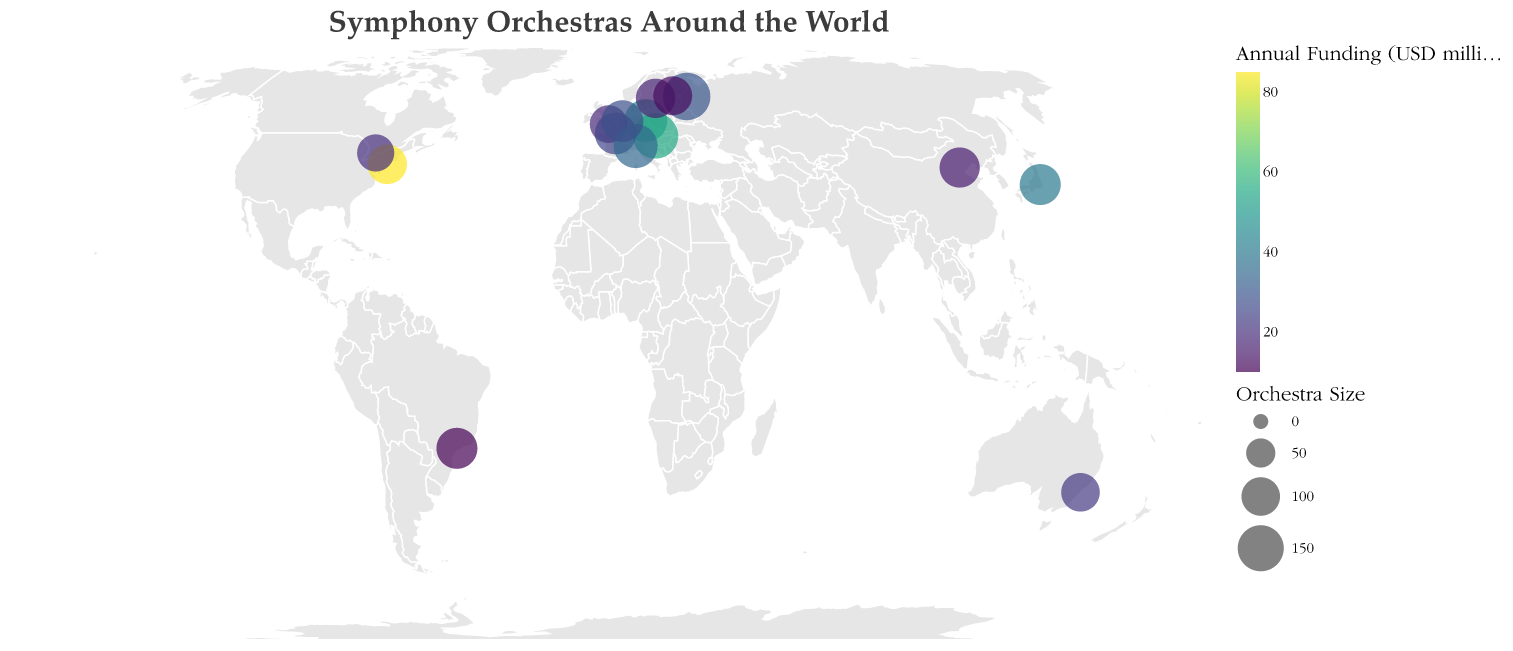What is the size of the New York Philharmonic orchestra? Look at the circle representing the New York Philharmonic in New York and refer to the size legend. The size is listed as 106.
Answer: 106 Which orchestra has the largest annual funding? Identify the orchestra with the most intense color indicating high funding. The New York Philharmonic in the United States has the highest funding of 85 million USD annually.
Answer: New York Philharmonic How many orchestras have an annual funding of 30 million USD or more? Count the circles with color intensity indicating 30 million USD or more. The orchestras are New York Philharmonic, Berlin Philharmonic, Vienna Philharmonic, and NHK Symphony Orchestra, totaling 4.
Answer: 4 Which orchestra has the smallest size under 100 members? Find the smallest circles and check their specific sizes. The London Symphony Orchestra has the smallest size of 95.
Answer: London Symphony Orchestra What is the average size of the orchestras in Europe? Identify the European orchestras (Berlin Philharmonic, London Symphony Orchestra, Vienna Philharmonic, Mariinsky Theatre Orchestra, Orchestre de Paris, La Scala Theatre Orchestra, Royal Concertgebouw Orchestra, Royal Stockholm Philharmonic, Helsinki Philharmonic Orchestra) and compute their average size. (128 + 95 + 145 + 160 + 119 + 135 + 120 + 105 + 102) / 9 = 123.22
Answer: 123.22 Which orchestra is located in the southern hemisphere? Locate the orchestras in the southern hemisphere by geographical position below the equator. The Sydney Symphony Orchestra in Australia is the one located there.
Answer: Sydney Symphony Orchestra How does the size of the NHK Symphony Orchestra compare to that of the Vienna Philharmonic? Compare the size of the NHK Symphony Orchestra (115) with the Vienna Philharmonic (145). The Vienna Philharmonic is larger.
Answer: Vienna Philharmonic is larger Among the orchestras listed, which country has the most symphony orchestras? Count the symphony orchestras for each country. Each listed country has one symphony orchestra, so no country has more than another.
Answer: Each country has one orchestra What is the combined annual funding for the orchestras in North America? Identify North American orchestras (New York Philharmonic and Toronto Symphony Orchestra) and sum their annual funding. 85 + 20 = 105
Answer: 105 How many orchestras have a size of more than 110 members? Count the circles representing orchestras with sizes greater than 110. Orchestras are Berlin Philharmonic, Vienna Philharmonic, Mariinsky Theatre Orchestra, NHK Symphony Orchestra, Orchestre de Paris, La Scala Theatre Orchestra, Royal Concertgebouw Orchestra, and São Paulo Symphony Orchestra, totaling 8.
Answer: 8 